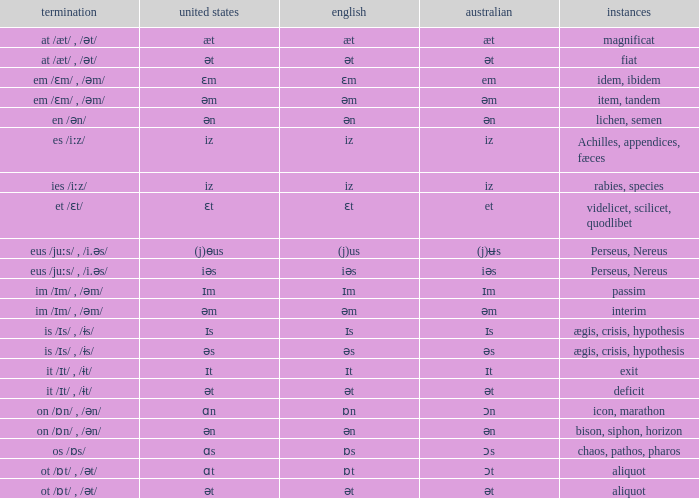Which Australian has British of ɒs? Ɔs. 